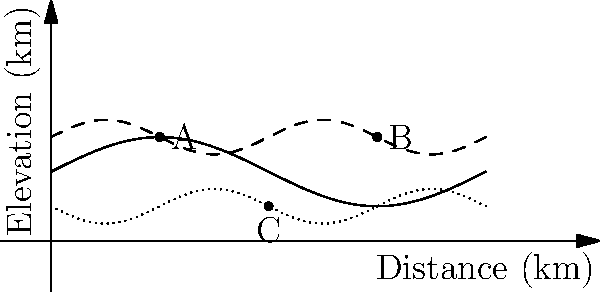Based on the topographical map shown, which location (A, B, or C) would be most suitable for planting a new vineyard, considering factors such as elevation, slope, and sunlight exposure? To determine the most suitable location for a new vineyard, we need to consider several factors:

1. Elevation: Vineyards typically perform well at moderate elevations, which provide a balance between temperature and sunlight exposure.

2. Slope: A gentle slope is ideal for vineyards as it provides good drainage and air circulation while minimizing erosion risks.

3. Sunlight exposure: South-facing slopes in the Northern Hemisphere generally receive more sunlight, which is beneficial for grape ripening.

Analyzing the three locations:

A: Located at a moderate elevation with a gentle slope. The curve suggests it's on the upper part of a hill, likely receiving good sunlight exposure.

B: Situated at a higher elevation with a steeper slope. While it may receive good sunlight, the steeper slope could lead to erosion and drainage issues.

C: Found at a lower elevation in what appears to be a valley. It may have limited sunlight exposure and potential for cold air pooling, which can increase frost risk.

Considering these factors, location A provides the best balance of elevation, slope, and potential sunlight exposure for a vineyard.
Answer: A 